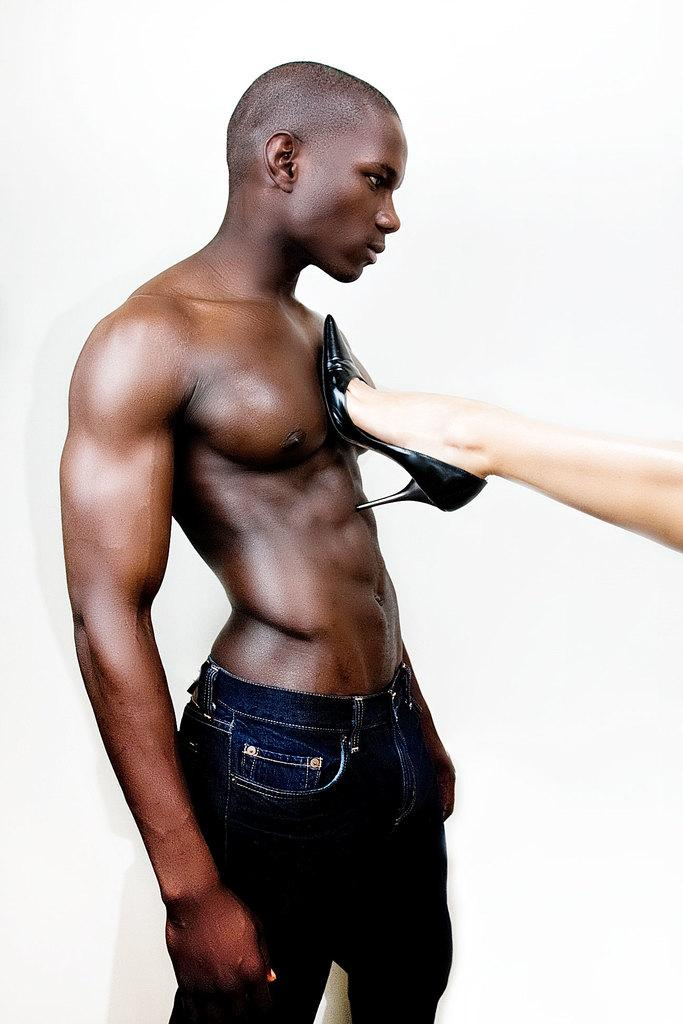What is the main subject of the image? There is a person standing in the image. What is the person wearing? The person is wearing black pants. Can you describe the interaction between the two people in the image? Another person's leg is on the standing person. What is the color of the background in the image? The background of the image is white. What type of toothbrush is the person using in the image? There is no toothbrush present in the image. Is there any blood visible on the person's leg in the image? There is no blood visible on the person's leg in the image. 